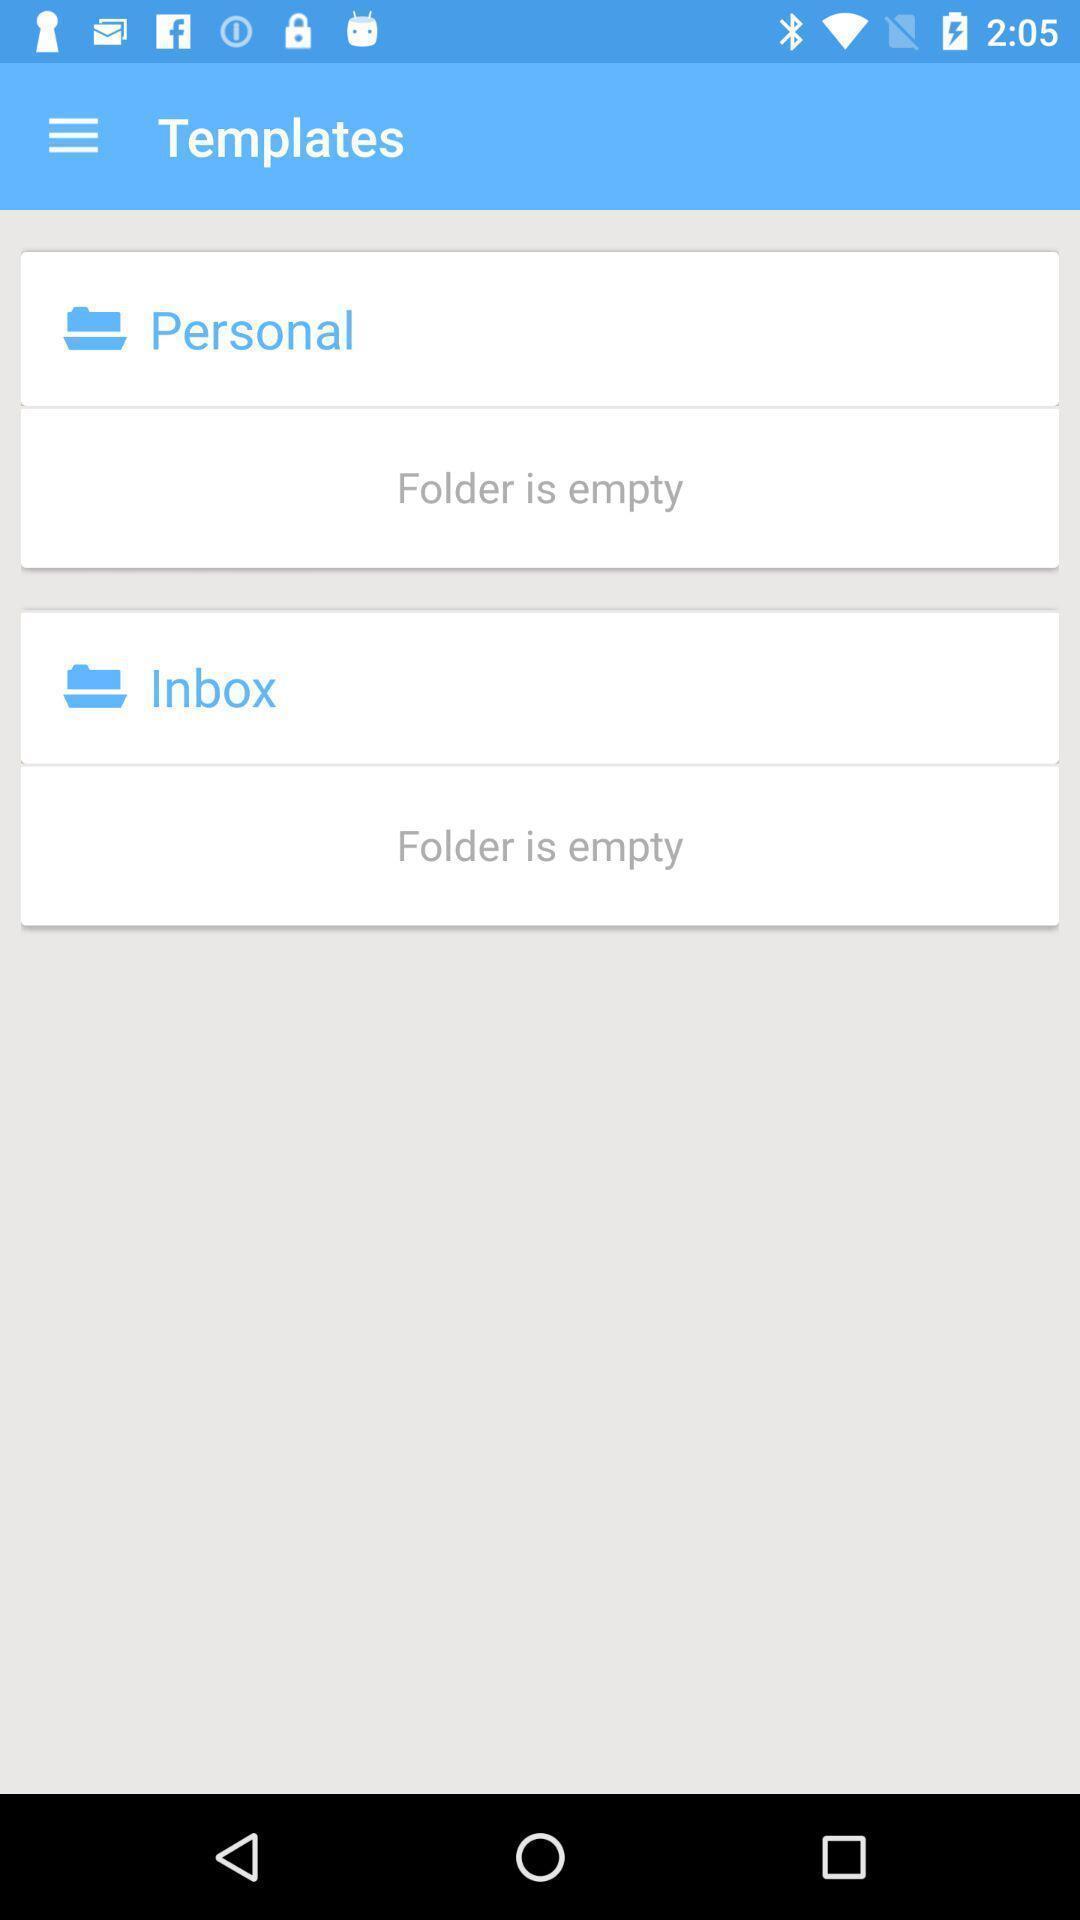What details can you identify in this image? Page displaying folder is empty. 